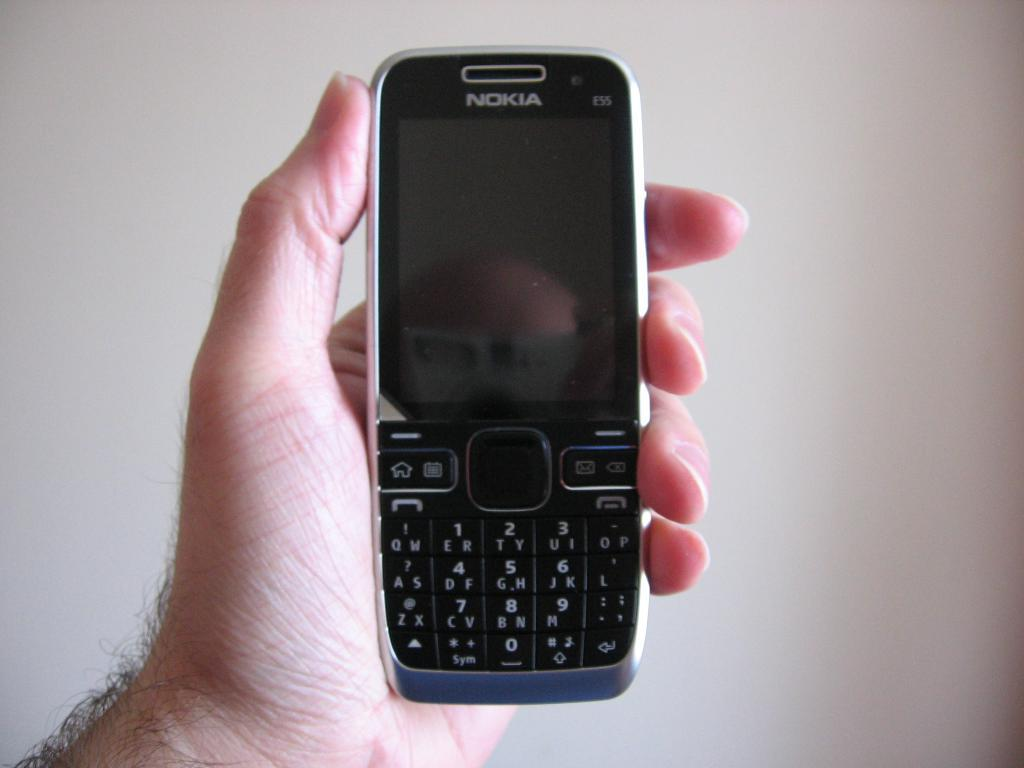<image>
Write a terse but informative summary of the picture. A HAND HOLDING A NOKIA PHONE WITH A BLANK SCREEN 